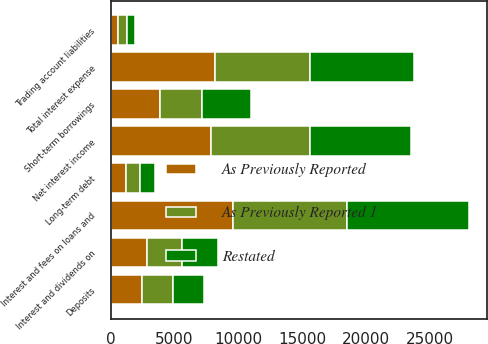<chart> <loc_0><loc_0><loc_500><loc_500><stacked_bar_chart><ecel><fcel>Interest and fees on loans and<fcel>Interest and dividends on<fcel>Deposits<fcel>Short-term borrowings<fcel>Trading account liabilities<fcel>Long-term debt<fcel>Total interest expense<fcel>Net interest income<nl><fcel>As Previously Reported<fcel>9559<fcel>2819<fcel>2434<fcel>3902<fcel>619<fcel>1215<fcel>8170<fcel>7860<nl><fcel>Restated<fcel>9536<fcel>2815<fcel>2476<fcel>3855<fcel>619<fcel>1209<fcel>8159<fcel>7859<nl><fcel>As Previously Reported 1<fcel>8956<fcel>2797<fcel>2439<fcel>3250<fcel>707<fcel>1053<fcel>7449<fcel>7773<nl></chart> 